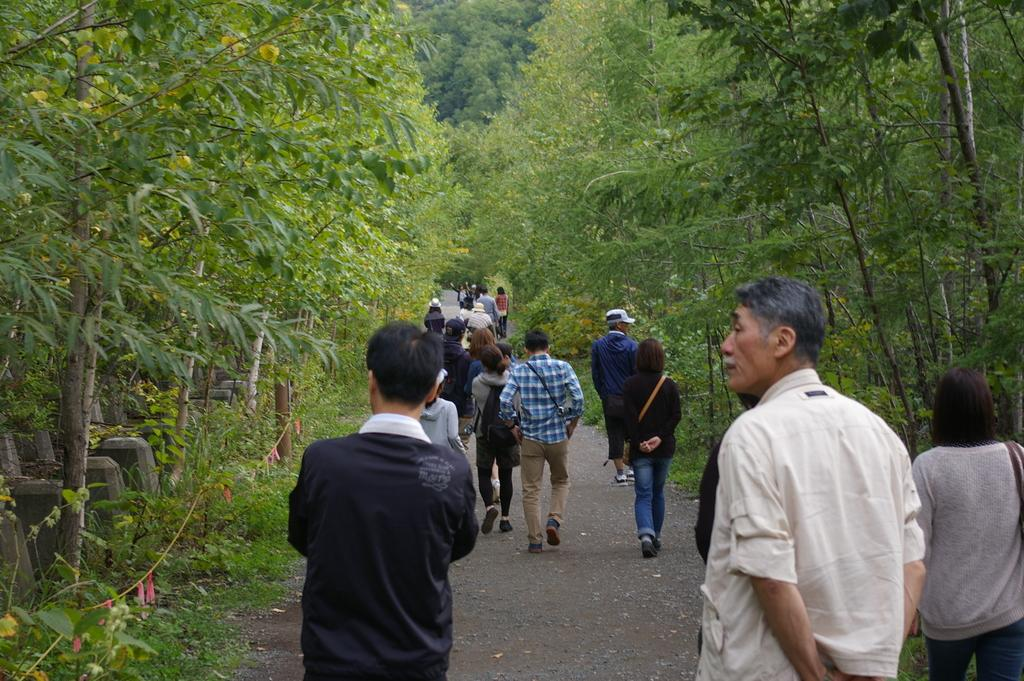What are the people in the image doing? The people in the image are walking. Where are the people walking? The people are walking on a path. What can be seen on either side of the path? There are trees on either side of the path. What is visible in the background of the image? There are trees in the background of the image. What type of marble can be seen on the path in the image? There is no marble present on the path in the image; it is a natural path with trees on either side. What kind of machine is being used by the people walking in the image? There is no machine visible in the image; the people are simply walking on a path surrounded by trees. 